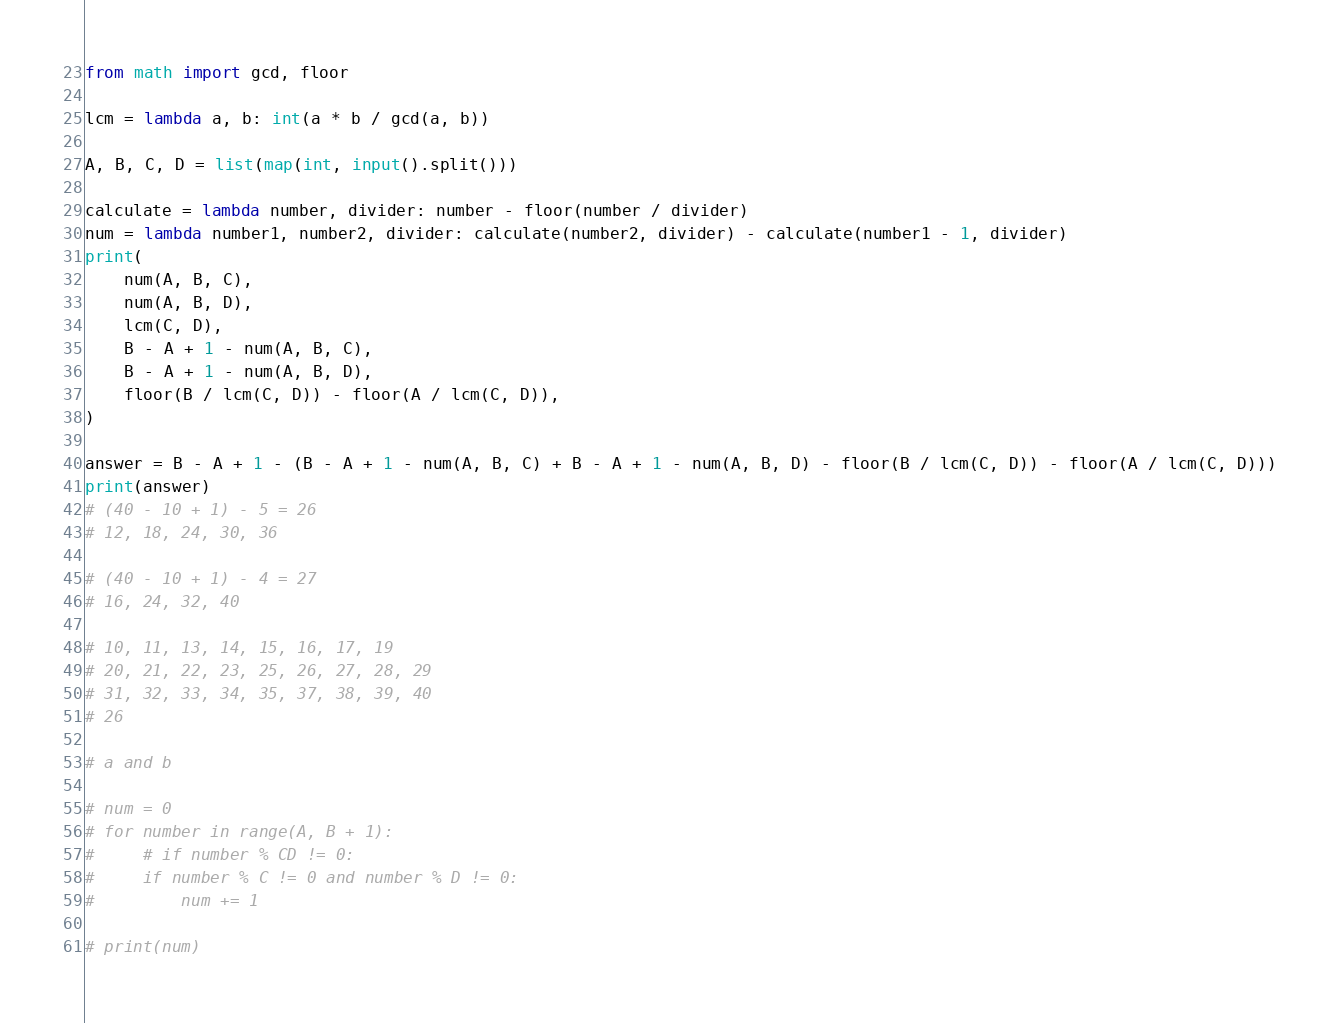<code> <loc_0><loc_0><loc_500><loc_500><_Python_>from math import gcd, floor

lcm = lambda a, b: int(a * b / gcd(a, b))

A, B, C, D = list(map(int, input().split()))

calculate = lambda number, divider: number - floor(number / divider)
num = lambda number1, number2, divider: calculate(number2, divider) - calculate(number1 - 1, divider)
print(
    num(A, B, C),
    num(A, B, D),
    lcm(C, D),
    B - A + 1 - num(A, B, C),
    B - A + 1 - num(A, B, D),
    floor(B / lcm(C, D)) - floor(A / lcm(C, D)),
)

answer = B - A + 1 - (B - A + 1 - num(A, B, C) + B - A + 1 - num(A, B, D) - floor(B / lcm(C, D)) - floor(A / lcm(C, D)))
print(answer)
# (40 - 10 + 1) - 5 = 26
# 12, 18, 24, 30, 36

# (40 - 10 + 1) - 4 = 27
# 16, 24, 32, 40

# 10, 11, 13, 14, 15, 16, 17, 19
# 20, 21, 22, 23, 25, 26, 27, 28, 29
# 31, 32, 33, 34, 35, 37, 38, 39, 40
# 26

# a and b

# num = 0
# for number in range(A, B + 1):
#     # if number % CD != 0:
#     if number % C != 0 and number % D != 0:
#         num += 1

# print(num)
</code> 